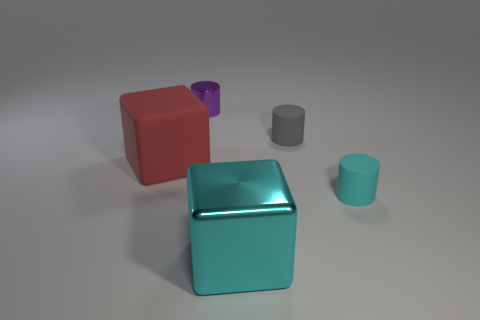Add 5 cyan cylinders. How many objects exist? 10 Subtract all cylinders. How many objects are left? 2 Subtract 0 blue balls. How many objects are left? 5 Subtract all big brown shiny blocks. Subtract all purple shiny cylinders. How many objects are left? 4 Add 5 gray rubber things. How many gray rubber things are left? 6 Add 1 gray rubber objects. How many gray rubber objects exist? 2 